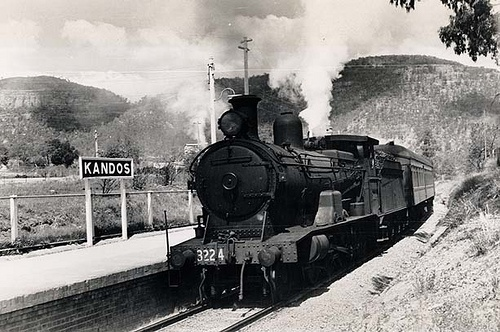Describe the objects in this image and their specific colors. I can see a train in lightgray, black, gray, and darkgray tones in this image. 